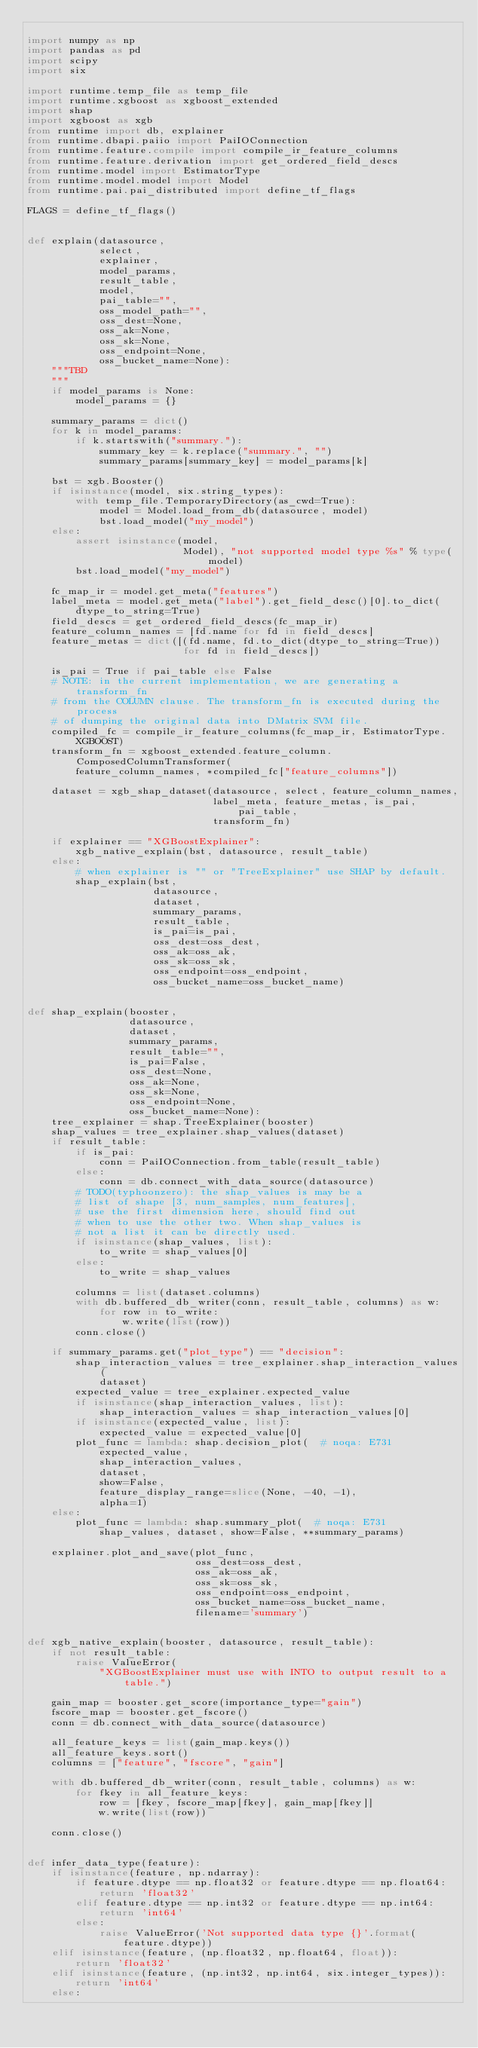Convert code to text. <code><loc_0><loc_0><loc_500><loc_500><_Python_>
import numpy as np
import pandas as pd
import scipy
import six

import runtime.temp_file as temp_file
import runtime.xgboost as xgboost_extended
import shap
import xgboost as xgb
from runtime import db, explainer
from runtime.dbapi.paiio import PaiIOConnection
from runtime.feature.compile import compile_ir_feature_columns
from runtime.feature.derivation import get_ordered_field_descs
from runtime.model import EstimatorType
from runtime.model.model import Model
from runtime.pai.pai_distributed import define_tf_flags

FLAGS = define_tf_flags()


def explain(datasource,
            select,
            explainer,
            model_params,
            result_table,
            model,
            pai_table="",
            oss_model_path="",
            oss_dest=None,
            oss_ak=None,
            oss_sk=None,
            oss_endpoint=None,
            oss_bucket_name=None):
    """TBD
    """
    if model_params is None:
        model_params = {}

    summary_params = dict()
    for k in model_params:
        if k.startswith("summary."):
            summary_key = k.replace("summary.", "")
            summary_params[summary_key] = model_params[k]

    bst = xgb.Booster()
    if isinstance(model, six.string_types):
        with temp_file.TemporaryDirectory(as_cwd=True):
            model = Model.load_from_db(datasource, model)
            bst.load_model("my_model")
    else:
        assert isinstance(model,
                          Model), "not supported model type %s" % type(model)
        bst.load_model("my_model")

    fc_map_ir = model.get_meta("features")
    label_meta = model.get_meta("label").get_field_desc()[0].to_dict(
        dtype_to_string=True)
    field_descs = get_ordered_field_descs(fc_map_ir)
    feature_column_names = [fd.name for fd in field_descs]
    feature_metas = dict([(fd.name, fd.to_dict(dtype_to_string=True))
                          for fd in field_descs])

    is_pai = True if pai_table else False
    # NOTE: in the current implementation, we are generating a transform_fn
    # from the COLUMN clause. The transform_fn is executed during the process
    # of dumping the original data into DMatrix SVM file.
    compiled_fc = compile_ir_feature_columns(fc_map_ir, EstimatorType.XGBOOST)
    transform_fn = xgboost_extended.feature_column.ComposedColumnTransformer(
        feature_column_names, *compiled_fc["feature_columns"])

    dataset = xgb_shap_dataset(datasource, select, feature_column_names,
                               label_meta, feature_metas, is_pai, pai_table,
                               transform_fn)

    if explainer == "XGBoostExplainer":
        xgb_native_explain(bst, datasource, result_table)
    else:
        # when explainer is "" or "TreeExplainer" use SHAP by default.
        shap_explain(bst,
                     datasource,
                     dataset,
                     summary_params,
                     result_table,
                     is_pai=is_pai,
                     oss_dest=oss_dest,
                     oss_ak=oss_ak,
                     oss_sk=oss_sk,
                     oss_endpoint=oss_endpoint,
                     oss_bucket_name=oss_bucket_name)


def shap_explain(booster,
                 datasource,
                 dataset,
                 summary_params,
                 result_table="",
                 is_pai=False,
                 oss_dest=None,
                 oss_ak=None,
                 oss_sk=None,
                 oss_endpoint=None,
                 oss_bucket_name=None):
    tree_explainer = shap.TreeExplainer(booster)
    shap_values = tree_explainer.shap_values(dataset)
    if result_table:
        if is_pai:
            conn = PaiIOConnection.from_table(result_table)
        else:
            conn = db.connect_with_data_source(datasource)
        # TODO(typhoonzero): the shap_values is may be a
        # list of shape [3, num_samples, num_features],
        # use the first dimension here, should find out
        # when to use the other two. When shap_values is
        # not a list it can be directly used.
        if isinstance(shap_values, list):
            to_write = shap_values[0]
        else:
            to_write = shap_values

        columns = list(dataset.columns)
        with db.buffered_db_writer(conn, result_table, columns) as w:
            for row in to_write:
                w.write(list(row))
        conn.close()

    if summary_params.get("plot_type") == "decision":
        shap_interaction_values = tree_explainer.shap_interaction_values(
            dataset)
        expected_value = tree_explainer.expected_value
        if isinstance(shap_interaction_values, list):
            shap_interaction_values = shap_interaction_values[0]
        if isinstance(expected_value, list):
            expected_value = expected_value[0]
        plot_func = lambda: shap.decision_plot(  # noqa: E731
            expected_value,
            shap_interaction_values,
            dataset,
            show=False,
            feature_display_range=slice(None, -40, -1),
            alpha=1)
    else:
        plot_func = lambda: shap.summary_plot(  # noqa: E731
            shap_values, dataset, show=False, **summary_params)

    explainer.plot_and_save(plot_func,
                            oss_dest=oss_dest,
                            oss_ak=oss_ak,
                            oss_sk=oss_sk,
                            oss_endpoint=oss_endpoint,
                            oss_bucket_name=oss_bucket_name,
                            filename='summary')


def xgb_native_explain(booster, datasource, result_table):
    if not result_table:
        raise ValueError(
            "XGBoostExplainer must use with INTO to output result to a table.")

    gain_map = booster.get_score(importance_type="gain")
    fscore_map = booster.get_fscore()
    conn = db.connect_with_data_source(datasource)

    all_feature_keys = list(gain_map.keys())
    all_feature_keys.sort()
    columns = ["feature", "fscore", "gain"]

    with db.buffered_db_writer(conn, result_table, columns) as w:
        for fkey in all_feature_keys:
            row = [fkey, fscore_map[fkey], gain_map[fkey]]
            w.write(list(row))

    conn.close()


def infer_data_type(feature):
    if isinstance(feature, np.ndarray):
        if feature.dtype == np.float32 or feature.dtype == np.float64:
            return 'float32'
        elif feature.dtype == np.int32 or feature.dtype == np.int64:
            return 'int64'
        else:
            raise ValueError('Not supported data type {}'.format(
                feature.dtype))
    elif isinstance(feature, (np.float32, np.float64, float)):
        return 'float32'
    elif isinstance(feature, (np.int32, np.int64, six.integer_types)):
        return 'int64'
    else:</code> 